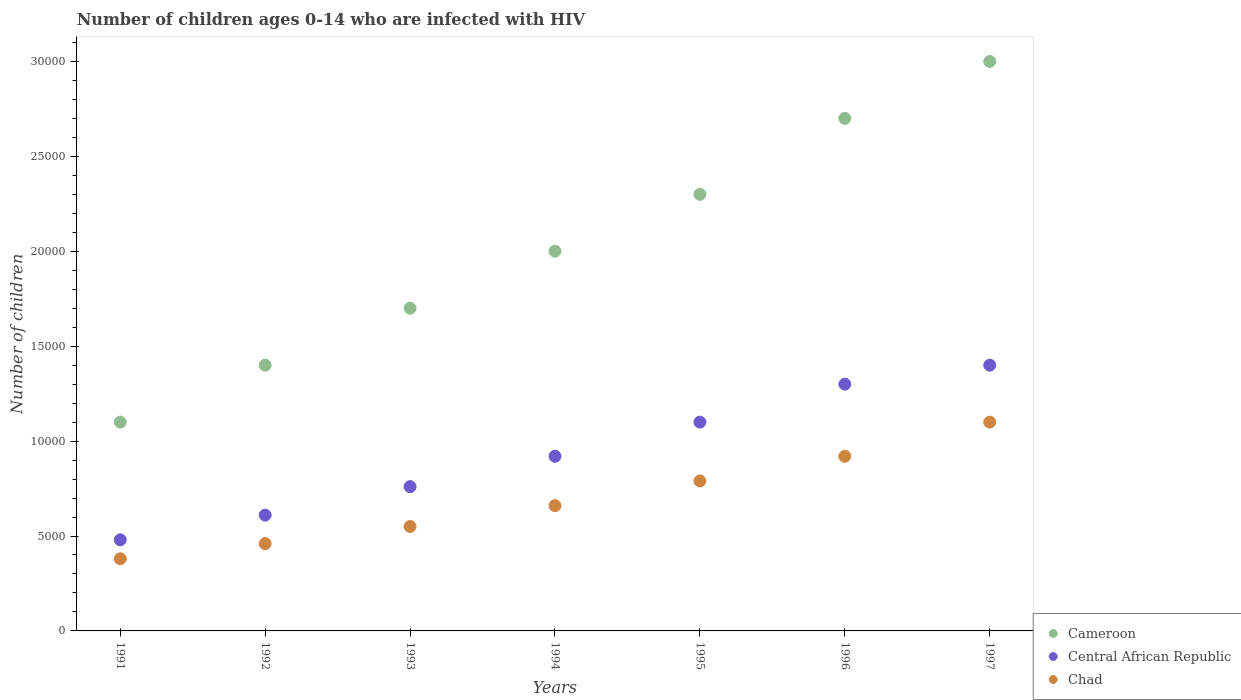What is the number of HIV infected children in Chad in 1994?
Ensure brevity in your answer.  6600. Across all years, what is the maximum number of HIV infected children in Cameroon?
Offer a terse response. 3.00e+04. Across all years, what is the minimum number of HIV infected children in Chad?
Make the answer very short. 3800. What is the total number of HIV infected children in Chad in the graph?
Provide a short and direct response. 4.86e+04. What is the difference between the number of HIV infected children in Central African Republic in 1994 and that in 1995?
Ensure brevity in your answer.  -1800. What is the difference between the number of HIV infected children in Cameroon in 1994 and the number of HIV infected children in Central African Republic in 1997?
Your answer should be compact. 6000. What is the average number of HIV infected children in Central African Republic per year?
Make the answer very short. 9385.71. In the year 1995, what is the difference between the number of HIV infected children in Chad and number of HIV infected children in Cameroon?
Provide a short and direct response. -1.51e+04. In how many years, is the number of HIV infected children in Chad greater than 4000?
Keep it short and to the point. 6. What is the ratio of the number of HIV infected children in Central African Republic in 1994 to that in 1996?
Your answer should be compact. 0.71. Is the number of HIV infected children in Chad in 1991 less than that in 1993?
Ensure brevity in your answer.  Yes. What is the difference between the highest and the second highest number of HIV infected children in Central African Republic?
Give a very brief answer. 1000. What is the difference between the highest and the lowest number of HIV infected children in Central African Republic?
Provide a succinct answer. 9200. Is it the case that in every year, the sum of the number of HIV infected children in Cameroon and number of HIV infected children in Chad  is greater than the number of HIV infected children in Central African Republic?
Provide a succinct answer. Yes. Does the number of HIV infected children in Cameroon monotonically increase over the years?
Your answer should be compact. Yes. Is the number of HIV infected children in Chad strictly less than the number of HIV infected children in Central African Republic over the years?
Your answer should be very brief. Yes. How many years are there in the graph?
Ensure brevity in your answer.  7. What is the difference between two consecutive major ticks on the Y-axis?
Ensure brevity in your answer.  5000. Are the values on the major ticks of Y-axis written in scientific E-notation?
Provide a short and direct response. No. Does the graph contain grids?
Your response must be concise. No. How are the legend labels stacked?
Ensure brevity in your answer.  Vertical. What is the title of the graph?
Your answer should be very brief. Number of children ages 0-14 who are infected with HIV. What is the label or title of the Y-axis?
Provide a short and direct response. Number of children. What is the Number of children of Cameroon in 1991?
Provide a succinct answer. 1.10e+04. What is the Number of children in Central African Republic in 1991?
Your answer should be very brief. 4800. What is the Number of children in Chad in 1991?
Offer a very short reply. 3800. What is the Number of children of Cameroon in 1992?
Provide a short and direct response. 1.40e+04. What is the Number of children in Central African Republic in 1992?
Give a very brief answer. 6100. What is the Number of children of Chad in 1992?
Ensure brevity in your answer.  4600. What is the Number of children of Cameroon in 1993?
Your answer should be compact. 1.70e+04. What is the Number of children in Central African Republic in 1993?
Offer a terse response. 7600. What is the Number of children of Chad in 1993?
Ensure brevity in your answer.  5500. What is the Number of children in Cameroon in 1994?
Ensure brevity in your answer.  2.00e+04. What is the Number of children of Central African Republic in 1994?
Give a very brief answer. 9200. What is the Number of children of Chad in 1994?
Make the answer very short. 6600. What is the Number of children of Cameroon in 1995?
Your answer should be very brief. 2.30e+04. What is the Number of children in Central African Republic in 1995?
Your answer should be compact. 1.10e+04. What is the Number of children in Chad in 1995?
Offer a very short reply. 7900. What is the Number of children in Cameroon in 1996?
Provide a succinct answer. 2.70e+04. What is the Number of children of Central African Republic in 1996?
Give a very brief answer. 1.30e+04. What is the Number of children of Chad in 1996?
Provide a short and direct response. 9200. What is the Number of children of Cameroon in 1997?
Your answer should be compact. 3.00e+04. What is the Number of children in Central African Republic in 1997?
Make the answer very short. 1.40e+04. What is the Number of children in Chad in 1997?
Your answer should be very brief. 1.10e+04. Across all years, what is the maximum Number of children of Cameroon?
Your answer should be very brief. 3.00e+04. Across all years, what is the maximum Number of children in Central African Republic?
Keep it short and to the point. 1.40e+04. Across all years, what is the maximum Number of children in Chad?
Keep it short and to the point. 1.10e+04. Across all years, what is the minimum Number of children in Cameroon?
Provide a short and direct response. 1.10e+04. Across all years, what is the minimum Number of children in Central African Republic?
Offer a very short reply. 4800. Across all years, what is the minimum Number of children of Chad?
Offer a terse response. 3800. What is the total Number of children in Cameroon in the graph?
Your response must be concise. 1.42e+05. What is the total Number of children of Central African Republic in the graph?
Offer a very short reply. 6.57e+04. What is the total Number of children in Chad in the graph?
Give a very brief answer. 4.86e+04. What is the difference between the Number of children in Cameroon in 1991 and that in 1992?
Offer a very short reply. -3000. What is the difference between the Number of children of Central African Republic in 1991 and that in 1992?
Ensure brevity in your answer.  -1300. What is the difference between the Number of children of Chad in 1991 and that in 1992?
Provide a succinct answer. -800. What is the difference between the Number of children in Cameroon in 1991 and that in 1993?
Give a very brief answer. -6000. What is the difference between the Number of children in Central African Republic in 1991 and that in 1993?
Keep it short and to the point. -2800. What is the difference between the Number of children in Chad in 1991 and that in 1993?
Offer a terse response. -1700. What is the difference between the Number of children in Cameroon in 1991 and that in 1994?
Offer a terse response. -9000. What is the difference between the Number of children in Central African Republic in 1991 and that in 1994?
Make the answer very short. -4400. What is the difference between the Number of children of Chad in 1991 and that in 1994?
Offer a terse response. -2800. What is the difference between the Number of children in Cameroon in 1991 and that in 1995?
Offer a very short reply. -1.20e+04. What is the difference between the Number of children of Central African Republic in 1991 and that in 1995?
Ensure brevity in your answer.  -6200. What is the difference between the Number of children in Chad in 1991 and that in 1995?
Keep it short and to the point. -4100. What is the difference between the Number of children in Cameroon in 1991 and that in 1996?
Keep it short and to the point. -1.60e+04. What is the difference between the Number of children of Central African Republic in 1991 and that in 1996?
Provide a short and direct response. -8200. What is the difference between the Number of children in Chad in 1991 and that in 1996?
Offer a terse response. -5400. What is the difference between the Number of children of Cameroon in 1991 and that in 1997?
Give a very brief answer. -1.90e+04. What is the difference between the Number of children in Central African Republic in 1991 and that in 1997?
Offer a very short reply. -9200. What is the difference between the Number of children in Chad in 1991 and that in 1997?
Provide a succinct answer. -7200. What is the difference between the Number of children in Cameroon in 1992 and that in 1993?
Keep it short and to the point. -3000. What is the difference between the Number of children of Central African Republic in 1992 and that in 1993?
Offer a terse response. -1500. What is the difference between the Number of children of Chad in 1992 and that in 1993?
Provide a short and direct response. -900. What is the difference between the Number of children of Cameroon in 1992 and that in 1994?
Offer a very short reply. -6000. What is the difference between the Number of children of Central African Republic in 1992 and that in 1994?
Your answer should be very brief. -3100. What is the difference between the Number of children in Chad in 1992 and that in 1994?
Give a very brief answer. -2000. What is the difference between the Number of children of Cameroon in 1992 and that in 1995?
Your response must be concise. -9000. What is the difference between the Number of children of Central African Republic in 1992 and that in 1995?
Ensure brevity in your answer.  -4900. What is the difference between the Number of children in Chad in 1992 and that in 1995?
Make the answer very short. -3300. What is the difference between the Number of children of Cameroon in 1992 and that in 1996?
Your answer should be compact. -1.30e+04. What is the difference between the Number of children in Central African Republic in 1992 and that in 1996?
Offer a terse response. -6900. What is the difference between the Number of children of Chad in 1992 and that in 1996?
Ensure brevity in your answer.  -4600. What is the difference between the Number of children of Cameroon in 1992 and that in 1997?
Give a very brief answer. -1.60e+04. What is the difference between the Number of children of Central African Republic in 1992 and that in 1997?
Ensure brevity in your answer.  -7900. What is the difference between the Number of children of Chad in 1992 and that in 1997?
Your answer should be compact. -6400. What is the difference between the Number of children in Cameroon in 1993 and that in 1994?
Provide a short and direct response. -3000. What is the difference between the Number of children in Central African Republic in 1993 and that in 1994?
Your answer should be very brief. -1600. What is the difference between the Number of children in Chad in 1993 and that in 1994?
Ensure brevity in your answer.  -1100. What is the difference between the Number of children of Cameroon in 1993 and that in 1995?
Your answer should be very brief. -6000. What is the difference between the Number of children of Central African Republic in 1993 and that in 1995?
Provide a short and direct response. -3400. What is the difference between the Number of children of Chad in 1993 and that in 1995?
Keep it short and to the point. -2400. What is the difference between the Number of children of Cameroon in 1993 and that in 1996?
Offer a very short reply. -10000. What is the difference between the Number of children in Central African Republic in 1993 and that in 1996?
Give a very brief answer. -5400. What is the difference between the Number of children of Chad in 1993 and that in 1996?
Provide a short and direct response. -3700. What is the difference between the Number of children of Cameroon in 1993 and that in 1997?
Give a very brief answer. -1.30e+04. What is the difference between the Number of children of Central African Republic in 1993 and that in 1997?
Provide a short and direct response. -6400. What is the difference between the Number of children in Chad in 1993 and that in 1997?
Give a very brief answer. -5500. What is the difference between the Number of children of Cameroon in 1994 and that in 1995?
Your answer should be compact. -3000. What is the difference between the Number of children in Central African Republic in 1994 and that in 1995?
Provide a succinct answer. -1800. What is the difference between the Number of children of Chad in 1994 and that in 1995?
Make the answer very short. -1300. What is the difference between the Number of children in Cameroon in 1994 and that in 1996?
Your answer should be very brief. -7000. What is the difference between the Number of children of Central African Republic in 1994 and that in 1996?
Provide a succinct answer. -3800. What is the difference between the Number of children of Chad in 1994 and that in 1996?
Offer a very short reply. -2600. What is the difference between the Number of children in Central African Republic in 1994 and that in 1997?
Ensure brevity in your answer.  -4800. What is the difference between the Number of children of Chad in 1994 and that in 1997?
Your response must be concise. -4400. What is the difference between the Number of children in Cameroon in 1995 and that in 1996?
Your answer should be compact. -4000. What is the difference between the Number of children of Central African Republic in 1995 and that in 1996?
Ensure brevity in your answer.  -2000. What is the difference between the Number of children in Chad in 1995 and that in 1996?
Your response must be concise. -1300. What is the difference between the Number of children of Cameroon in 1995 and that in 1997?
Keep it short and to the point. -7000. What is the difference between the Number of children in Central African Republic in 1995 and that in 1997?
Offer a very short reply. -3000. What is the difference between the Number of children in Chad in 1995 and that in 1997?
Provide a succinct answer. -3100. What is the difference between the Number of children of Cameroon in 1996 and that in 1997?
Provide a succinct answer. -3000. What is the difference between the Number of children in Central African Republic in 1996 and that in 1997?
Offer a very short reply. -1000. What is the difference between the Number of children of Chad in 1996 and that in 1997?
Keep it short and to the point. -1800. What is the difference between the Number of children in Cameroon in 1991 and the Number of children in Central African Republic in 1992?
Provide a short and direct response. 4900. What is the difference between the Number of children of Cameroon in 1991 and the Number of children of Chad in 1992?
Offer a terse response. 6400. What is the difference between the Number of children in Cameroon in 1991 and the Number of children in Central African Republic in 1993?
Ensure brevity in your answer.  3400. What is the difference between the Number of children of Cameroon in 1991 and the Number of children of Chad in 1993?
Provide a succinct answer. 5500. What is the difference between the Number of children of Central African Republic in 1991 and the Number of children of Chad in 1993?
Offer a terse response. -700. What is the difference between the Number of children in Cameroon in 1991 and the Number of children in Central African Republic in 1994?
Offer a terse response. 1800. What is the difference between the Number of children of Cameroon in 1991 and the Number of children of Chad in 1994?
Your answer should be compact. 4400. What is the difference between the Number of children in Central African Republic in 1991 and the Number of children in Chad in 1994?
Provide a succinct answer. -1800. What is the difference between the Number of children in Cameroon in 1991 and the Number of children in Chad in 1995?
Make the answer very short. 3100. What is the difference between the Number of children in Central African Republic in 1991 and the Number of children in Chad in 1995?
Offer a terse response. -3100. What is the difference between the Number of children of Cameroon in 1991 and the Number of children of Central African Republic in 1996?
Give a very brief answer. -2000. What is the difference between the Number of children of Cameroon in 1991 and the Number of children of Chad in 1996?
Give a very brief answer. 1800. What is the difference between the Number of children of Central African Republic in 1991 and the Number of children of Chad in 1996?
Offer a terse response. -4400. What is the difference between the Number of children in Cameroon in 1991 and the Number of children in Central African Republic in 1997?
Give a very brief answer. -3000. What is the difference between the Number of children in Central African Republic in 1991 and the Number of children in Chad in 1997?
Your answer should be very brief. -6200. What is the difference between the Number of children of Cameroon in 1992 and the Number of children of Central African Republic in 1993?
Ensure brevity in your answer.  6400. What is the difference between the Number of children of Cameroon in 1992 and the Number of children of Chad in 1993?
Make the answer very short. 8500. What is the difference between the Number of children of Central African Republic in 1992 and the Number of children of Chad in 1993?
Offer a terse response. 600. What is the difference between the Number of children of Cameroon in 1992 and the Number of children of Central African Republic in 1994?
Make the answer very short. 4800. What is the difference between the Number of children in Cameroon in 1992 and the Number of children in Chad in 1994?
Ensure brevity in your answer.  7400. What is the difference between the Number of children of Central African Republic in 1992 and the Number of children of Chad in 1994?
Offer a very short reply. -500. What is the difference between the Number of children in Cameroon in 1992 and the Number of children in Central African Republic in 1995?
Keep it short and to the point. 3000. What is the difference between the Number of children of Cameroon in 1992 and the Number of children of Chad in 1995?
Your response must be concise. 6100. What is the difference between the Number of children in Central African Republic in 1992 and the Number of children in Chad in 1995?
Keep it short and to the point. -1800. What is the difference between the Number of children of Cameroon in 1992 and the Number of children of Chad in 1996?
Provide a succinct answer. 4800. What is the difference between the Number of children of Central African Republic in 1992 and the Number of children of Chad in 1996?
Your response must be concise. -3100. What is the difference between the Number of children of Cameroon in 1992 and the Number of children of Central African Republic in 1997?
Offer a terse response. 0. What is the difference between the Number of children of Cameroon in 1992 and the Number of children of Chad in 1997?
Offer a terse response. 3000. What is the difference between the Number of children in Central African Republic in 1992 and the Number of children in Chad in 1997?
Offer a very short reply. -4900. What is the difference between the Number of children in Cameroon in 1993 and the Number of children in Central African Republic in 1994?
Offer a very short reply. 7800. What is the difference between the Number of children of Cameroon in 1993 and the Number of children of Chad in 1994?
Your answer should be very brief. 1.04e+04. What is the difference between the Number of children in Central African Republic in 1993 and the Number of children in Chad in 1994?
Your response must be concise. 1000. What is the difference between the Number of children in Cameroon in 1993 and the Number of children in Central African Republic in 1995?
Your answer should be very brief. 6000. What is the difference between the Number of children of Cameroon in 1993 and the Number of children of Chad in 1995?
Offer a terse response. 9100. What is the difference between the Number of children of Central African Republic in 1993 and the Number of children of Chad in 1995?
Offer a terse response. -300. What is the difference between the Number of children in Cameroon in 1993 and the Number of children in Central African Republic in 1996?
Offer a very short reply. 4000. What is the difference between the Number of children of Cameroon in 1993 and the Number of children of Chad in 1996?
Offer a terse response. 7800. What is the difference between the Number of children of Central African Republic in 1993 and the Number of children of Chad in 1996?
Offer a very short reply. -1600. What is the difference between the Number of children of Cameroon in 1993 and the Number of children of Central African Republic in 1997?
Offer a terse response. 3000. What is the difference between the Number of children in Cameroon in 1993 and the Number of children in Chad in 1997?
Make the answer very short. 6000. What is the difference between the Number of children in Central African Republic in 1993 and the Number of children in Chad in 1997?
Make the answer very short. -3400. What is the difference between the Number of children in Cameroon in 1994 and the Number of children in Central African Republic in 1995?
Your response must be concise. 9000. What is the difference between the Number of children of Cameroon in 1994 and the Number of children of Chad in 1995?
Give a very brief answer. 1.21e+04. What is the difference between the Number of children of Central African Republic in 1994 and the Number of children of Chad in 1995?
Keep it short and to the point. 1300. What is the difference between the Number of children in Cameroon in 1994 and the Number of children in Central African Republic in 1996?
Give a very brief answer. 7000. What is the difference between the Number of children of Cameroon in 1994 and the Number of children of Chad in 1996?
Your answer should be compact. 1.08e+04. What is the difference between the Number of children of Cameroon in 1994 and the Number of children of Central African Republic in 1997?
Your response must be concise. 6000. What is the difference between the Number of children in Cameroon in 1994 and the Number of children in Chad in 1997?
Make the answer very short. 9000. What is the difference between the Number of children of Central African Republic in 1994 and the Number of children of Chad in 1997?
Ensure brevity in your answer.  -1800. What is the difference between the Number of children in Cameroon in 1995 and the Number of children in Central African Republic in 1996?
Provide a succinct answer. 10000. What is the difference between the Number of children in Cameroon in 1995 and the Number of children in Chad in 1996?
Your answer should be very brief. 1.38e+04. What is the difference between the Number of children in Central African Republic in 1995 and the Number of children in Chad in 1996?
Ensure brevity in your answer.  1800. What is the difference between the Number of children of Cameroon in 1995 and the Number of children of Central African Republic in 1997?
Offer a very short reply. 9000. What is the difference between the Number of children in Cameroon in 1995 and the Number of children in Chad in 1997?
Provide a short and direct response. 1.20e+04. What is the difference between the Number of children in Central African Republic in 1995 and the Number of children in Chad in 1997?
Ensure brevity in your answer.  0. What is the difference between the Number of children in Cameroon in 1996 and the Number of children in Central African Republic in 1997?
Your answer should be compact. 1.30e+04. What is the difference between the Number of children of Cameroon in 1996 and the Number of children of Chad in 1997?
Your answer should be compact. 1.60e+04. What is the difference between the Number of children of Central African Republic in 1996 and the Number of children of Chad in 1997?
Give a very brief answer. 2000. What is the average Number of children in Cameroon per year?
Give a very brief answer. 2.03e+04. What is the average Number of children in Central African Republic per year?
Your response must be concise. 9385.71. What is the average Number of children in Chad per year?
Your answer should be very brief. 6942.86. In the year 1991, what is the difference between the Number of children of Cameroon and Number of children of Central African Republic?
Give a very brief answer. 6200. In the year 1991, what is the difference between the Number of children of Cameroon and Number of children of Chad?
Provide a short and direct response. 7200. In the year 1992, what is the difference between the Number of children in Cameroon and Number of children in Central African Republic?
Make the answer very short. 7900. In the year 1992, what is the difference between the Number of children in Cameroon and Number of children in Chad?
Provide a short and direct response. 9400. In the year 1992, what is the difference between the Number of children of Central African Republic and Number of children of Chad?
Keep it short and to the point. 1500. In the year 1993, what is the difference between the Number of children in Cameroon and Number of children in Central African Republic?
Offer a very short reply. 9400. In the year 1993, what is the difference between the Number of children in Cameroon and Number of children in Chad?
Provide a succinct answer. 1.15e+04. In the year 1993, what is the difference between the Number of children in Central African Republic and Number of children in Chad?
Ensure brevity in your answer.  2100. In the year 1994, what is the difference between the Number of children of Cameroon and Number of children of Central African Republic?
Your answer should be compact. 1.08e+04. In the year 1994, what is the difference between the Number of children of Cameroon and Number of children of Chad?
Provide a short and direct response. 1.34e+04. In the year 1994, what is the difference between the Number of children of Central African Republic and Number of children of Chad?
Your response must be concise. 2600. In the year 1995, what is the difference between the Number of children in Cameroon and Number of children in Central African Republic?
Offer a very short reply. 1.20e+04. In the year 1995, what is the difference between the Number of children in Cameroon and Number of children in Chad?
Ensure brevity in your answer.  1.51e+04. In the year 1995, what is the difference between the Number of children of Central African Republic and Number of children of Chad?
Provide a succinct answer. 3100. In the year 1996, what is the difference between the Number of children in Cameroon and Number of children in Central African Republic?
Offer a very short reply. 1.40e+04. In the year 1996, what is the difference between the Number of children in Cameroon and Number of children in Chad?
Your response must be concise. 1.78e+04. In the year 1996, what is the difference between the Number of children in Central African Republic and Number of children in Chad?
Give a very brief answer. 3800. In the year 1997, what is the difference between the Number of children of Cameroon and Number of children of Central African Republic?
Offer a terse response. 1.60e+04. In the year 1997, what is the difference between the Number of children of Cameroon and Number of children of Chad?
Your response must be concise. 1.90e+04. In the year 1997, what is the difference between the Number of children of Central African Republic and Number of children of Chad?
Keep it short and to the point. 3000. What is the ratio of the Number of children of Cameroon in 1991 to that in 1992?
Offer a terse response. 0.79. What is the ratio of the Number of children in Central African Republic in 1991 to that in 1992?
Your response must be concise. 0.79. What is the ratio of the Number of children in Chad in 1991 to that in 1992?
Your answer should be very brief. 0.83. What is the ratio of the Number of children in Cameroon in 1991 to that in 1993?
Provide a short and direct response. 0.65. What is the ratio of the Number of children in Central African Republic in 1991 to that in 1993?
Provide a short and direct response. 0.63. What is the ratio of the Number of children of Chad in 1991 to that in 1993?
Provide a succinct answer. 0.69. What is the ratio of the Number of children in Cameroon in 1991 to that in 1994?
Keep it short and to the point. 0.55. What is the ratio of the Number of children of Central African Republic in 1991 to that in 1994?
Give a very brief answer. 0.52. What is the ratio of the Number of children of Chad in 1991 to that in 1994?
Your response must be concise. 0.58. What is the ratio of the Number of children of Cameroon in 1991 to that in 1995?
Provide a short and direct response. 0.48. What is the ratio of the Number of children in Central African Republic in 1991 to that in 1995?
Give a very brief answer. 0.44. What is the ratio of the Number of children of Chad in 1991 to that in 1995?
Ensure brevity in your answer.  0.48. What is the ratio of the Number of children of Cameroon in 1991 to that in 1996?
Provide a succinct answer. 0.41. What is the ratio of the Number of children of Central African Republic in 1991 to that in 1996?
Your answer should be very brief. 0.37. What is the ratio of the Number of children of Chad in 1991 to that in 1996?
Provide a succinct answer. 0.41. What is the ratio of the Number of children of Cameroon in 1991 to that in 1997?
Provide a succinct answer. 0.37. What is the ratio of the Number of children in Central African Republic in 1991 to that in 1997?
Give a very brief answer. 0.34. What is the ratio of the Number of children in Chad in 1991 to that in 1997?
Make the answer very short. 0.35. What is the ratio of the Number of children of Cameroon in 1992 to that in 1993?
Provide a succinct answer. 0.82. What is the ratio of the Number of children of Central African Republic in 1992 to that in 1993?
Offer a terse response. 0.8. What is the ratio of the Number of children of Chad in 1992 to that in 1993?
Offer a very short reply. 0.84. What is the ratio of the Number of children in Cameroon in 1992 to that in 1994?
Provide a succinct answer. 0.7. What is the ratio of the Number of children of Central African Republic in 1992 to that in 1994?
Offer a terse response. 0.66. What is the ratio of the Number of children in Chad in 1992 to that in 1994?
Ensure brevity in your answer.  0.7. What is the ratio of the Number of children in Cameroon in 1992 to that in 1995?
Give a very brief answer. 0.61. What is the ratio of the Number of children of Central African Republic in 1992 to that in 1995?
Provide a succinct answer. 0.55. What is the ratio of the Number of children of Chad in 1992 to that in 1995?
Your response must be concise. 0.58. What is the ratio of the Number of children in Cameroon in 1992 to that in 1996?
Ensure brevity in your answer.  0.52. What is the ratio of the Number of children of Central African Republic in 1992 to that in 1996?
Give a very brief answer. 0.47. What is the ratio of the Number of children of Chad in 1992 to that in 1996?
Provide a succinct answer. 0.5. What is the ratio of the Number of children in Cameroon in 1992 to that in 1997?
Offer a very short reply. 0.47. What is the ratio of the Number of children of Central African Republic in 1992 to that in 1997?
Keep it short and to the point. 0.44. What is the ratio of the Number of children in Chad in 1992 to that in 1997?
Your answer should be compact. 0.42. What is the ratio of the Number of children of Cameroon in 1993 to that in 1994?
Give a very brief answer. 0.85. What is the ratio of the Number of children in Central African Republic in 1993 to that in 1994?
Provide a succinct answer. 0.83. What is the ratio of the Number of children of Chad in 1993 to that in 1994?
Give a very brief answer. 0.83. What is the ratio of the Number of children of Cameroon in 1993 to that in 1995?
Provide a short and direct response. 0.74. What is the ratio of the Number of children in Central African Republic in 1993 to that in 1995?
Provide a short and direct response. 0.69. What is the ratio of the Number of children in Chad in 1993 to that in 1995?
Your answer should be very brief. 0.7. What is the ratio of the Number of children of Cameroon in 1993 to that in 1996?
Your answer should be very brief. 0.63. What is the ratio of the Number of children of Central African Republic in 1993 to that in 1996?
Give a very brief answer. 0.58. What is the ratio of the Number of children of Chad in 1993 to that in 1996?
Your answer should be very brief. 0.6. What is the ratio of the Number of children in Cameroon in 1993 to that in 1997?
Ensure brevity in your answer.  0.57. What is the ratio of the Number of children in Central African Republic in 1993 to that in 1997?
Your response must be concise. 0.54. What is the ratio of the Number of children of Cameroon in 1994 to that in 1995?
Your answer should be very brief. 0.87. What is the ratio of the Number of children of Central African Republic in 1994 to that in 1995?
Ensure brevity in your answer.  0.84. What is the ratio of the Number of children in Chad in 1994 to that in 1995?
Offer a terse response. 0.84. What is the ratio of the Number of children in Cameroon in 1994 to that in 1996?
Offer a terse response. 0.74. What is the ratio of the Number of children in Central African Republic in 1994 to that in 1996?
Provide a short and direct response. 0.71. What is the ratio of the Number of children of Chad in 1994 to that in 1996?
Offer a very short reply. 0.72. What is the ratio of the Number of children of Central African Republic in 1994 to that in 1997?
Offer a very short reply. 0.66. What is the ratio of the Number of children of Cameroon in 1995 to that in 1996?
Ensure brevity in your answer.  0.85. What is the ratio of the Number of children in Central African Republic in 1995 to that in 1996?
Give a very brief answer. 0.85. What is the ratio of the Number of children of Chad in 1995 to that in 1996?
Offer a terse response. 0.86. What is the ratio of the Number of children in Cameroon in 1995 to that in 1997?
Offer a terse response. 0.77. What is the ratio of the Number of children in Central African Republic in 1995 to that in 1997?
Your answer should be very brief. 0.79. What is the ratio of the Number of children of Chad in 1995 to that in 1997?
Keep it short and to the point. 0.72. What is the ratio of the Number of children in Cameroon in 1996 to that in 1997?
Provide a short and direct response. 0.9. What is the ratio of the Number of children in Chad in 1996 to that in 1997?
Your response must be concise. 0.84. What is the difference between the highest and the second highest Number of children of Cameroon?
Give a very brief answer. 3000. What is the difference between the highest and the second highest Number of children in Chad?
Ensure brevity in your answer.  1800. What is the difference between the highest and the lowest Number of children in Cameroon?
Your answer should be compact. 1.90e+04. What is the difference between the highest and the lowest Number of children of Central African Republic?
Make the answer very short. 9200. What is the difference between the highest and the lowest Number of children of Chad?
Your answer should be very brief. 7200. 